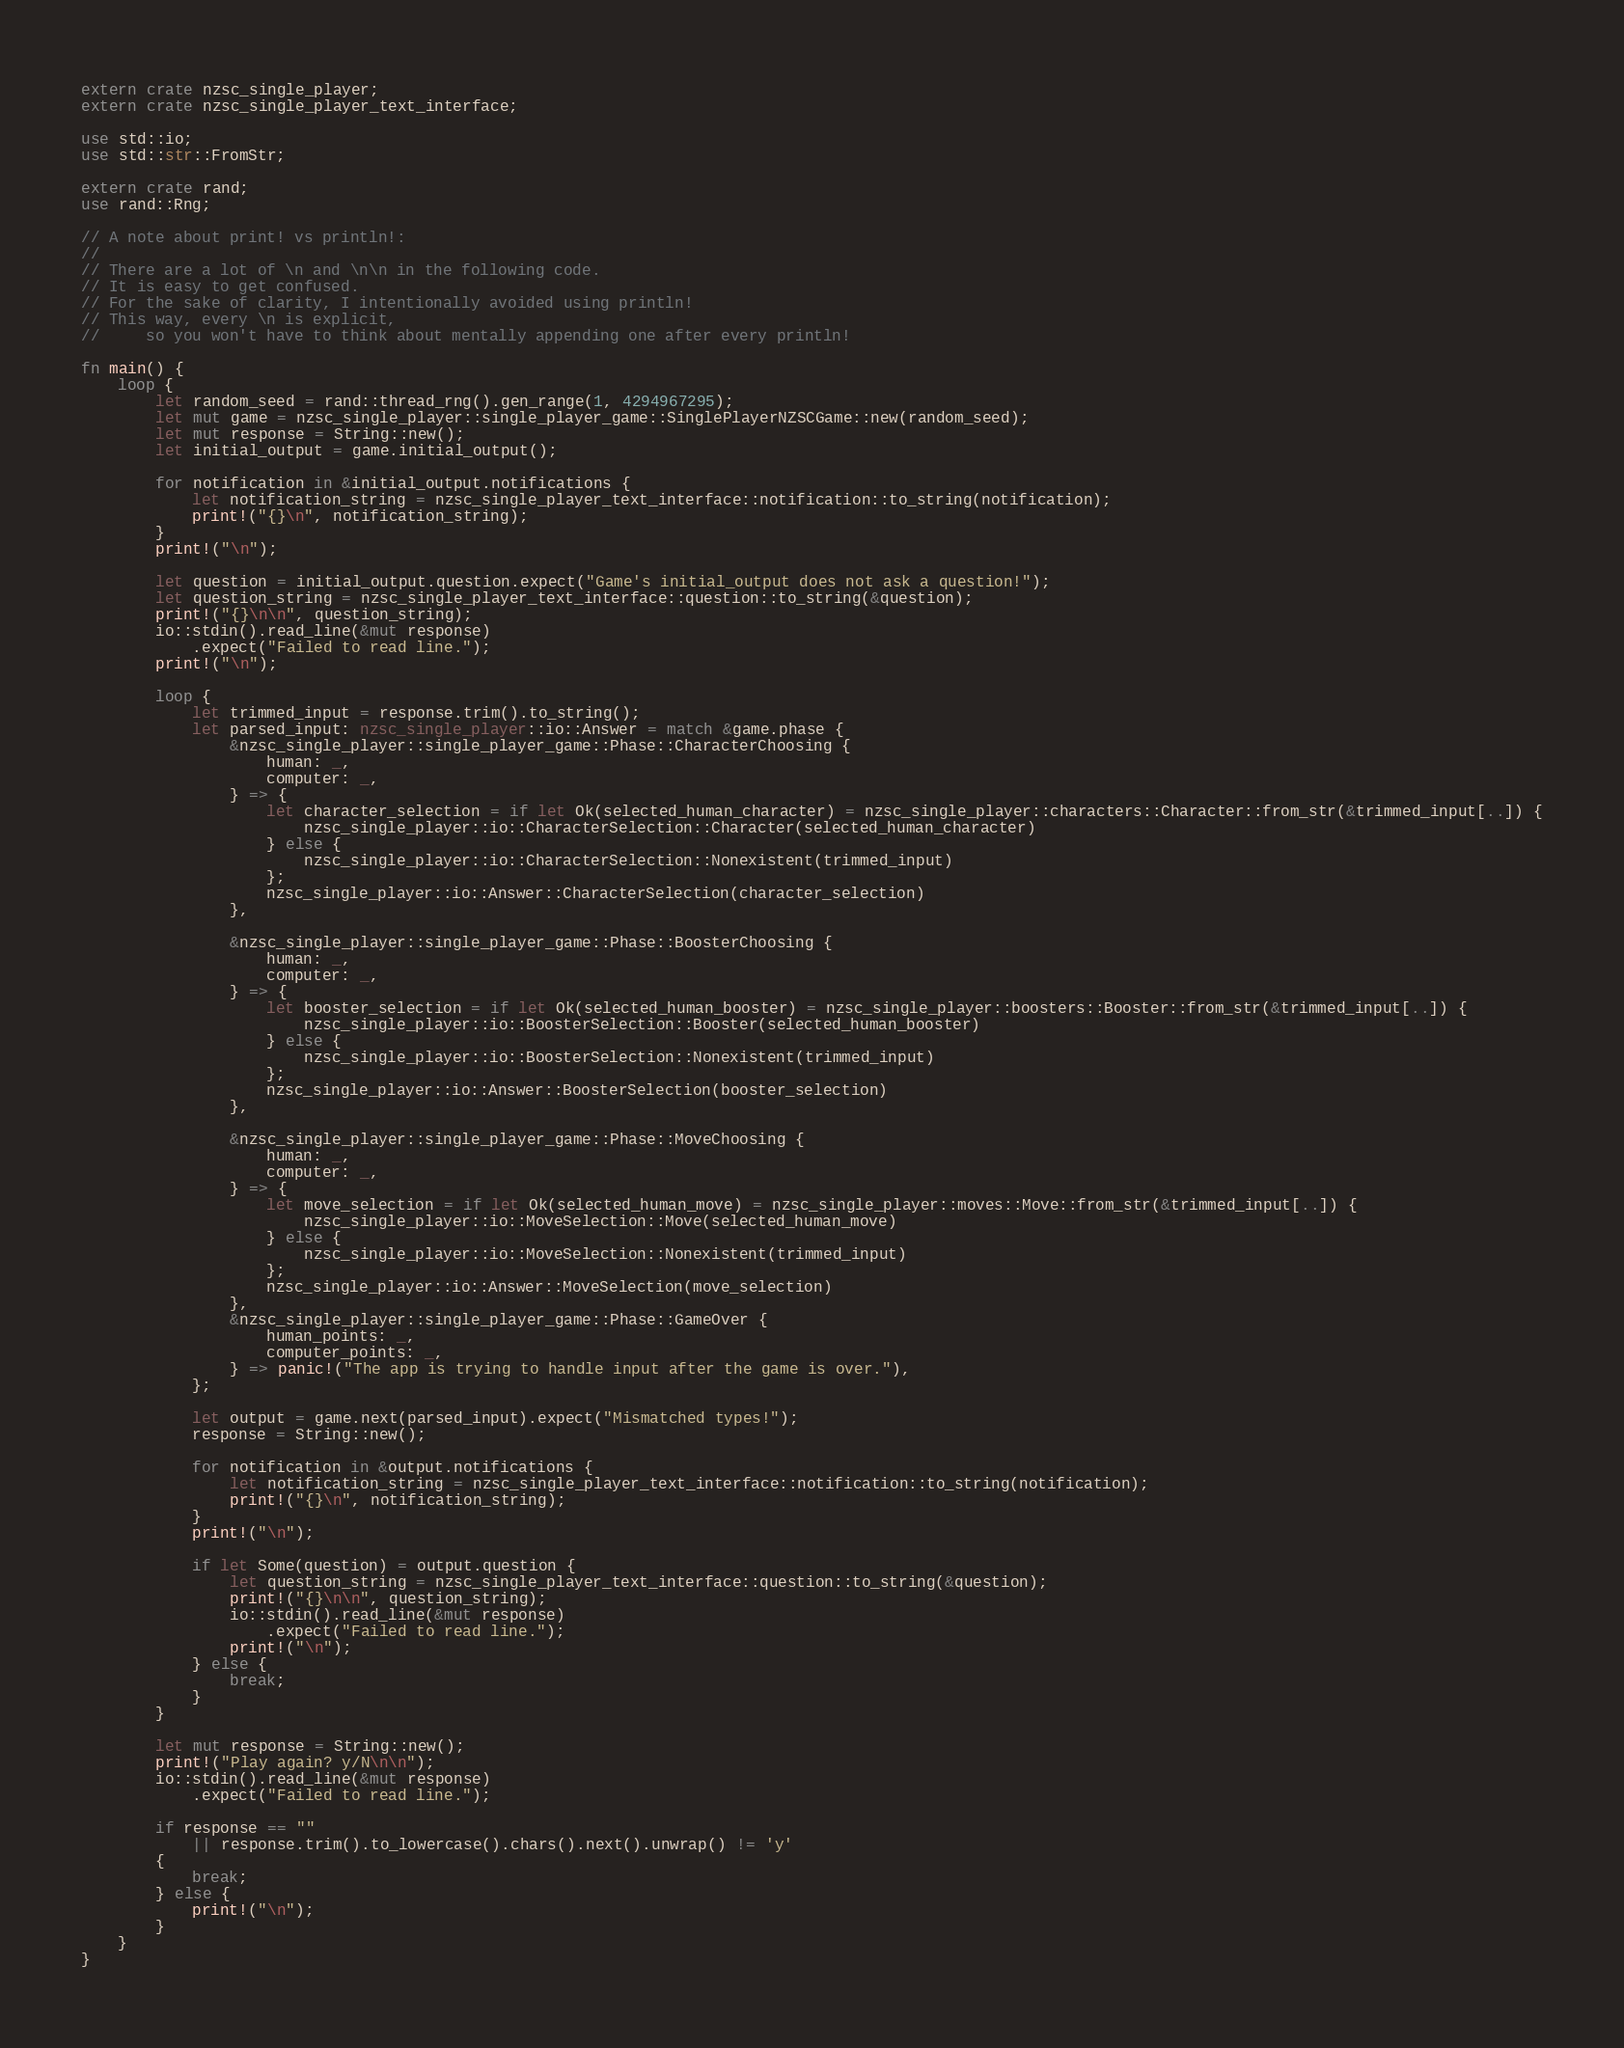Convert code to text. <code><loc_0><loc_0><loc_500><loc_500><_Rust_>extern crate nzsc_single_player;
extern crate nzsc_single_player_text_interface;

use std::io;
use std::str::FromStr;

extern crate rand;
use rand::Rng;

// A note about print! vs println!:
//
// There are a lot of \n and \n\n in the following code.
// It is easy to get confused.
// For the sake of clarity, I intentionally avoided using println!
// This way, every \n is explicit,
//     so you won't have to think about mentally appending one after every println!

fn main() {
    loop {
        let random_seed = rand::thread_rng().gen_range(1, 4294967295);
        let mut game = nzsc_single_player::single_player_game::SinglePlayerNZSCGame::new(random_seed);
        let mut response = String::new();
        let initial_output = game.initial_output();

        for notification in &initial_output.notifications {
            let notification_string = nzsc_single_player_text_interface::notification::to_string(notification);
            print!("{}\n", notification_string);
        }
        print!("\n");

        let question = initial_output.question.expect("Game's initial_output does not ask a question!");
        let question_string = nzsc_single_player_text_interface::question::to_string(&question);
        print!("{}\n\n", question_string);
        io::stdin().read_line(&mut response)
            .expect("Failed to read line.");
        print!("\n");

        loop {
            let trimmed_input = response.trim().to_string();
            let parsed_input: nzsc_single_player::io::Answer = match &game.phase {
                &nzsc_single_player::single_player_game::Phase::CharacterChoosing {
                    human: _,
                    computer: _,
                } => {
                    let character_selection = if let Ok(selected_human_character) = nzsc_single_player::characters::Character::from_str(&trimmed_input[..]) {
                        nzsc_single_player::io::CharacterSelection::Character(selected_human_character)
                    } else {
                        nzsc_single_player::io::CharacterSelection::Nonexistent(trimmed_input)
                    };
                    nzsc_single_player::io::Answer::CharacterSelection(character_selection)
                },

                &nzsc_single_player::single_player_game::Phase::BoosterChoosing {
                    human: _,
                    computer: _,
                } => {
                    let booster_selection = if let Ok(selected_human_booster) = nzsc_single_player::boosters::Booster::from_str(&trimmed_input[..]) {
                        nzsc_single_player::io::BoosterSelection::Booster(selected_human_booster)
                    } else {
                        nzsc_single_player::io::BoosterSelection::Nonexistent(trimmed_input)
                    };
                    nzsc_single_player::io::Answer::BoosterSelection(booster_selection)
                },

                &nzsc_single_player::single_player_game::Phase::MoveChoosing {
                    human: _,
                    computer: _,
                } => {
                    let move_selection = if let Ok(selected_human_move) = nzsc_single_player::moves::Move::from_str(&trimmed_input[..]) {
                        nzsc_single_player::io::MoveSelection::Move(selected_human_move)
                    } else {
                        nzsc_single_player::io::MoveSelection::Nonexistent(trimmed_input)
                    };
                    nzsc_single_player::io::Answer::MoveSelection(move_selection)
                },
                &nzsc_single_player::single_player_game::Phase::GameOver {
                    human_points: _,
                    computer_points: _,
                } => panic!("The app is trying to handle input after the game is over."),
            };

            let output = game.next(parsed_input).expect("Mismatched types!");
            response = String::new();

            for notification in &output.notifications {
                let notification_string = nzsc_single_player_text_interface::notification::to_string(notification);
                print!("{}\n", notification_string);
            }
            print!("\n");

            if let Some(question) = output.question {
                let question_string = nzsc_single_player_text_interface::question::to_string(&question);
                print!("{}\n\n", question_string);
                io::stdin().read_line(&mut response)
                    .expect("Failed to read line.");
                print!("\n");
            } else {
                break;
            }
        }

        let mut response = String::new();
        print!("Play again? y/N\n\n");
        io::stdin().read_line(&mut response)
            .expect("Failed to read line.");

        if response == ""
            || response.trim().to_lowercase().chars().next().unwrap() != 'y'
        {
            break;
        } else {
            print!("\n");
        }
    }
}
</code> 